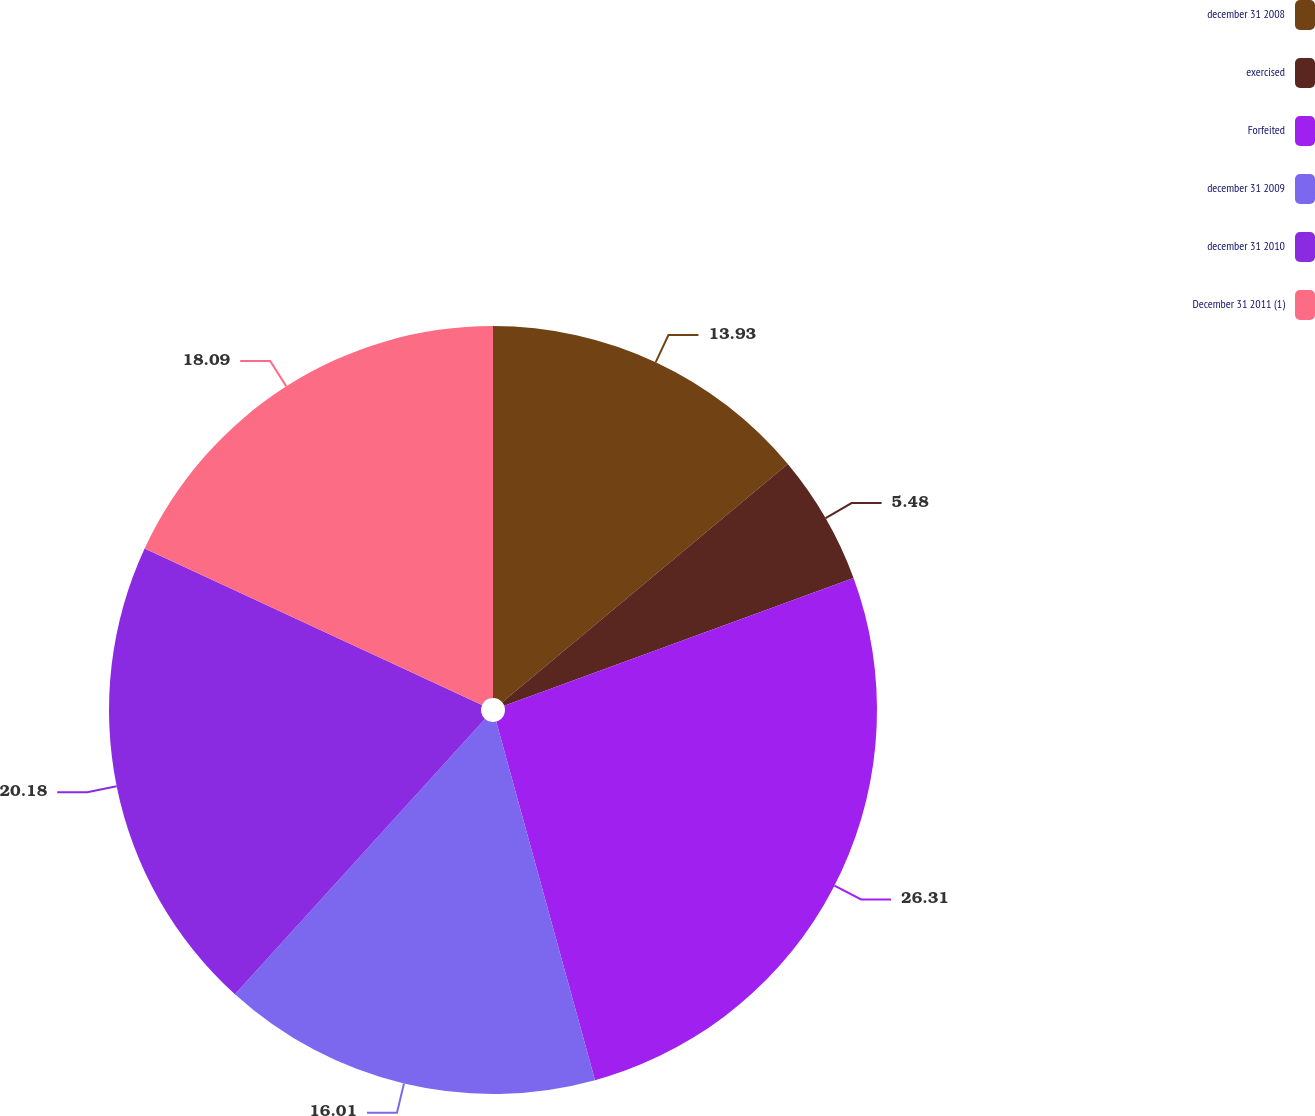Convert chart. <chart><loc_0><loc_0><loc_500><loc_500><pie_chart><fcel>december 31 2008<fcel>exercised<fcel>Forfeited<fcel>december 31 2009<fcel>december 31 2010<fcel>December 31 2011 (1)<nl><fcel>13.93%<fcel>5.48%<fcel>26.31%<fcel>16.01%<fcel>20.18%<fcel>18.09%<nl></chart> 